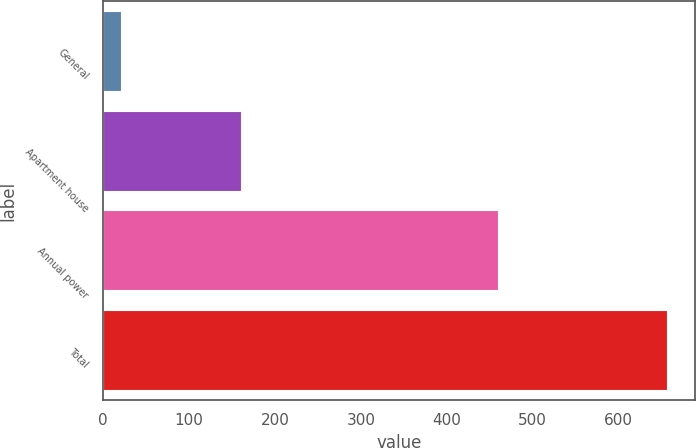<chart> <loc_0><loc_0><loc_500><loc_500><bar_chart><fcel>General<fcel>Apartment house<fcel>Annual power<fcel>Total<nl><fcel>21<fcel>160<fcel>459<fcel>656<nl></chart> 